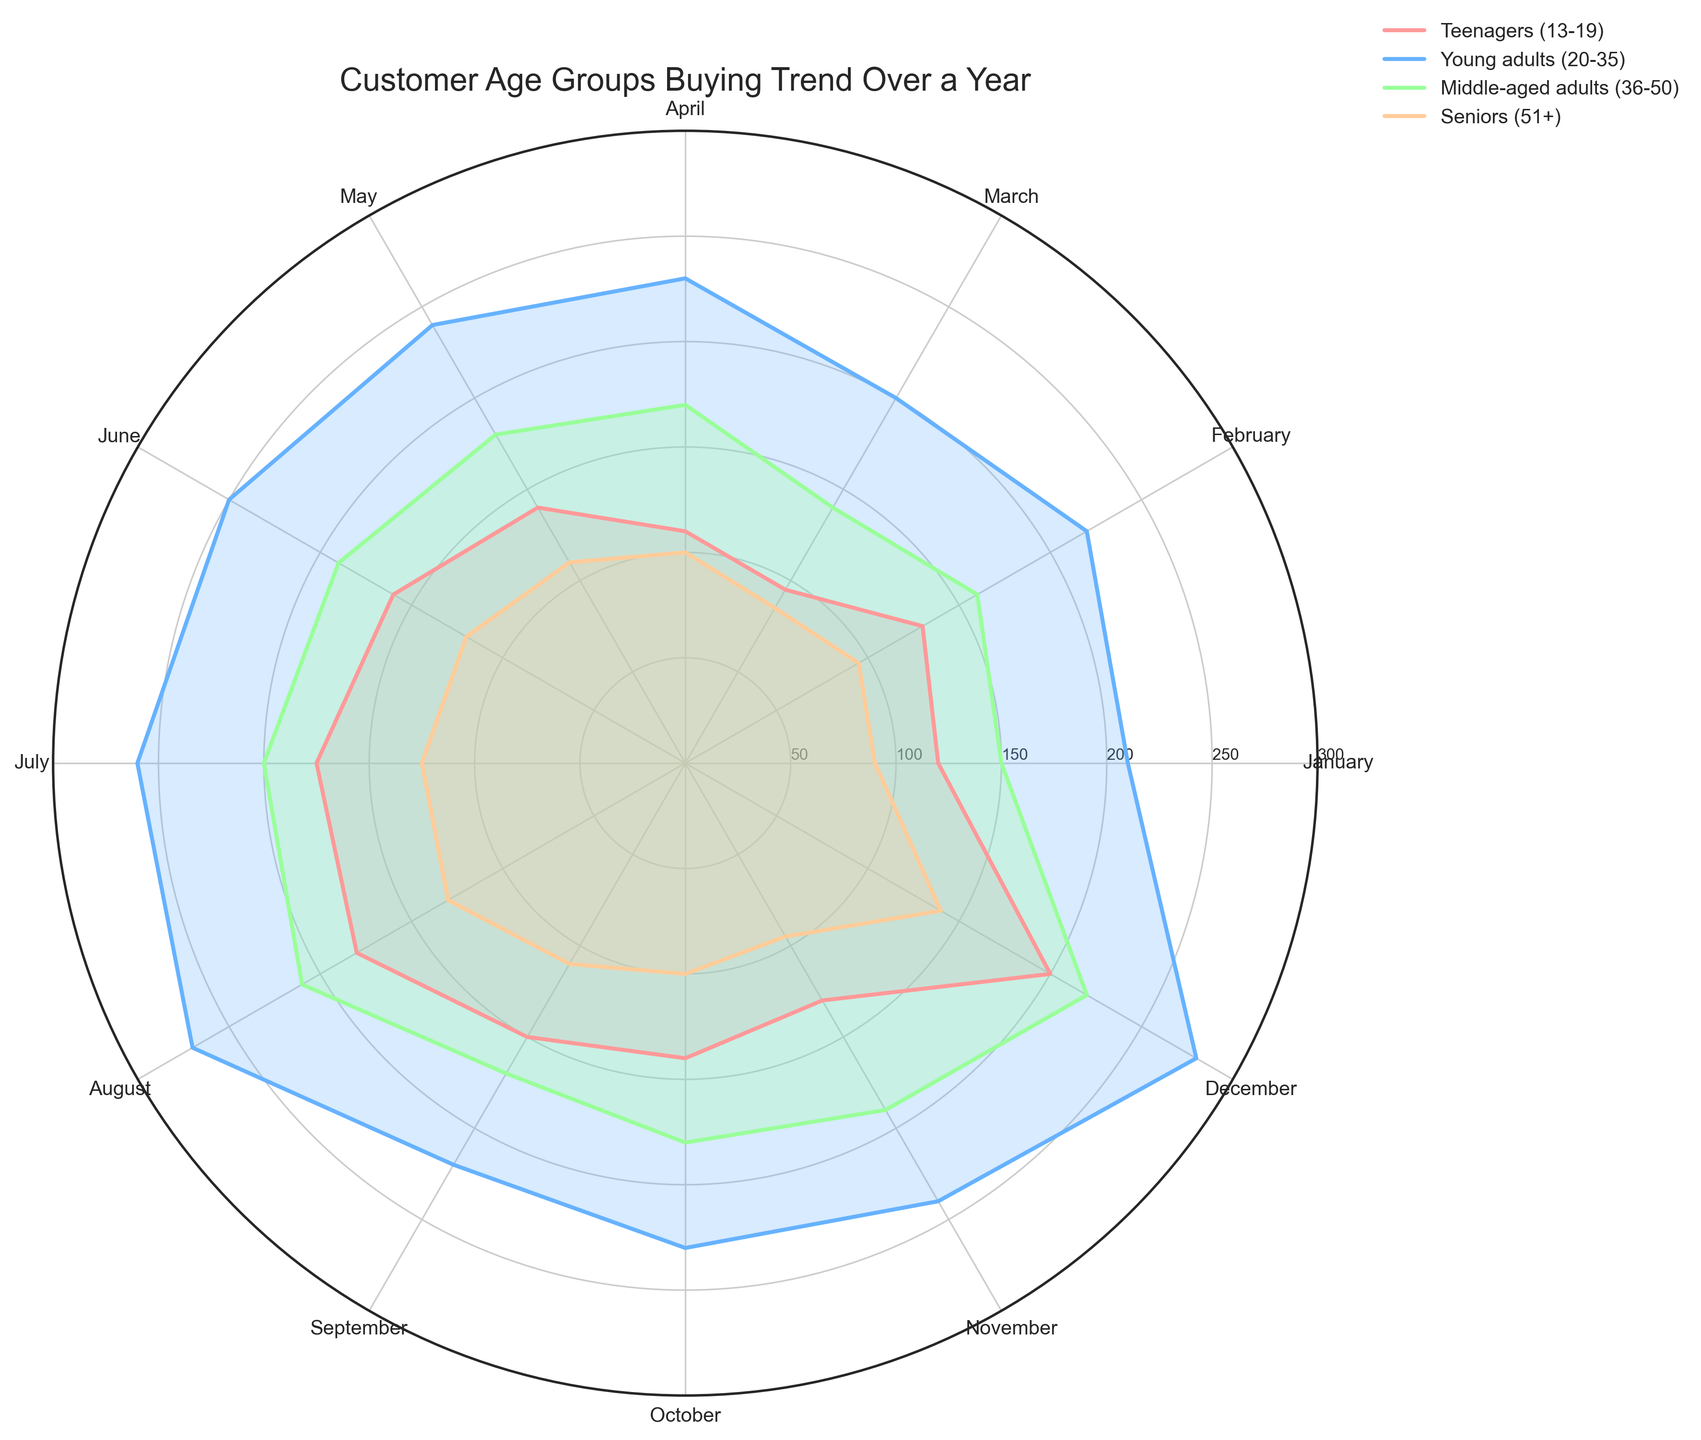Which month had the highest units sold among Young adults (20-35)? First, identify the plot line representing Young Adults (usually labeled). Then, find the month with the highest value along the radial axis. The largest spike for Young Adults is observed in December.
Answer: December Which age group had the lowest units sold in April? Locate the radial values for each age group in April. Compare the heights of these values. Seniors (51+) have the smallest value.
Answer: Seniors (51+) How does the trend of units sold over the year compare between Teenagers (13-19) and Middle-aged adults (36-50)? Identify the lines for both Teenagers and Middle-aged adults. Observe the trends and changes in the values throughout the months. Middle-aged adults have a more consistent and higher trend compared to the fluctuations seen in Teenagers.
Answer: Middle-aged adults are more consistent What is the average number of units sold in June across all age groups? Find the values for June for each age group: Teenagers (160), Young adults (250), Middle-aged adults (190), and Seniors (120). Sum these values and divide by the number of age groups (4). Calculation: (160 + 250 + 190 + 120) / 4 = 720 / 4 = 180.
Answer: 180 Which age group shows the most significant increase in units sold from November to December? Compare the November and December values for each age group and calculate the increase: Teenagers (130 to 200, +70), Young adults (240 to 280, +40), Middle-aged adults (190 to 220, +30), Seniors (95 to 140, +45). The most significant increase is for Teenagers.
Answer: Teenagers (13-19) In which month did Middle-aged adults (36-50) and Young adults (20-35) have the same units sold? Examine the values for each month for both Middle-aged adults (36-50) and Young adults (20-35). Look for matches. Both groups have 230 units sold in October.
Answer: October How does the volume of sales in Summer months (June, July, August) differ across the age groups? Focus on the values for June, July, and August for each age group and compare them. Teenagers increase steadily, Young adults have the highest volume, Middle-aged adults have a high but steady trend, and Seniors also show a steady trend with lower values.
Answer: Young adults have the highest volume in summer 